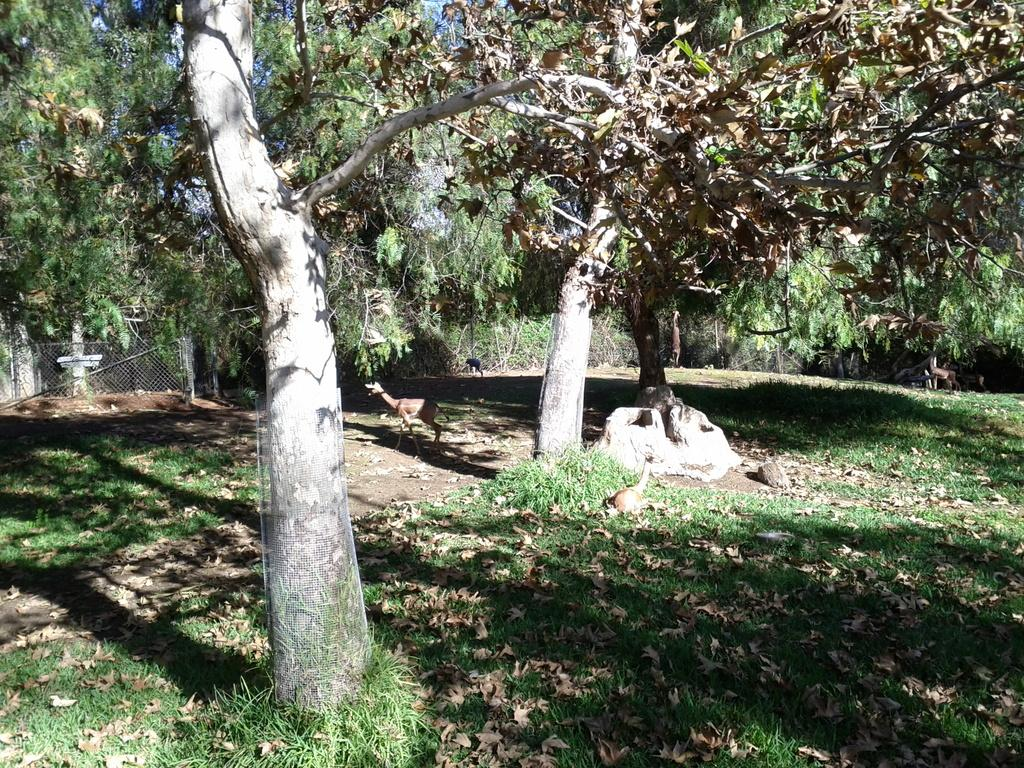What animal can be seen in the image? There is a deer in the image. What type of vegetation is present on the ground in the image? There is grass on the ground in the image. What additional natural elements can be seen in the image? There are dried leaves and trees in the image. What type of fencing is visible in the background of the image? There is mesh fencing in the background of the image. What type of club can be seen in the image? There is no club present in the image; it features a deer in a natural setting with grass, dried leaves, trees, and mesh fencing. 